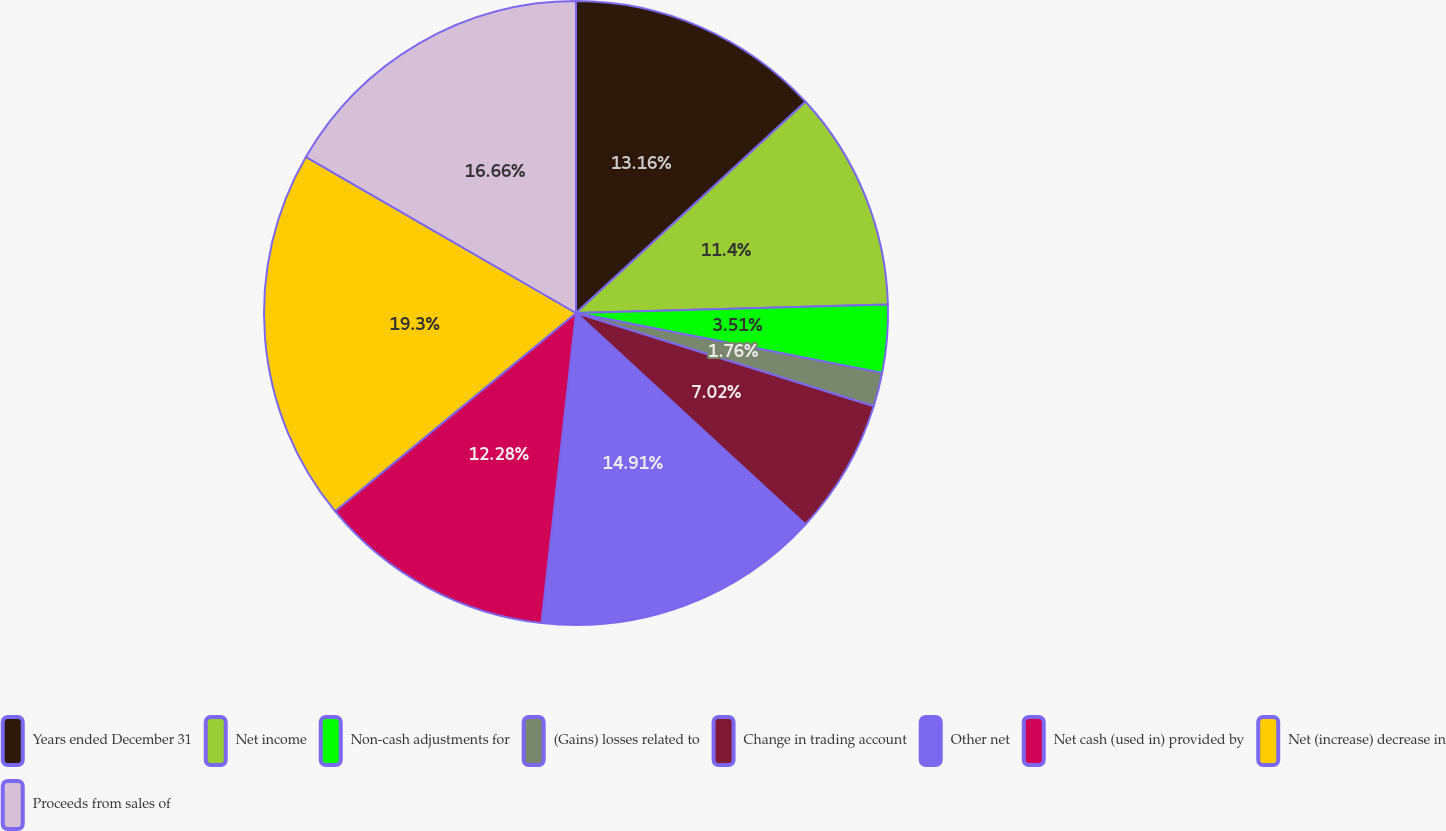<chart> <loc_0><loc_0><loc_500><loc_500><pie_chart><fcel>Years ended December 31<fcel>Net income<fcel>Non-cash adjustments for<fcel>(Gains) losses related to<fcel>Change in trading account<fcel>Other net<fcel>Net cash (used in) provided by<fcel>Net (increase) decrease in<fcel>Proceeds from sales of<nl><fcel>13.16%<fcel>11.4%<fcel>3.51%<fcel>1.76%<fcel>7.02%<fcel>14.91%<fcel>12.28%<fcel>19.29%<fcel>16.66%<nl></chart> 